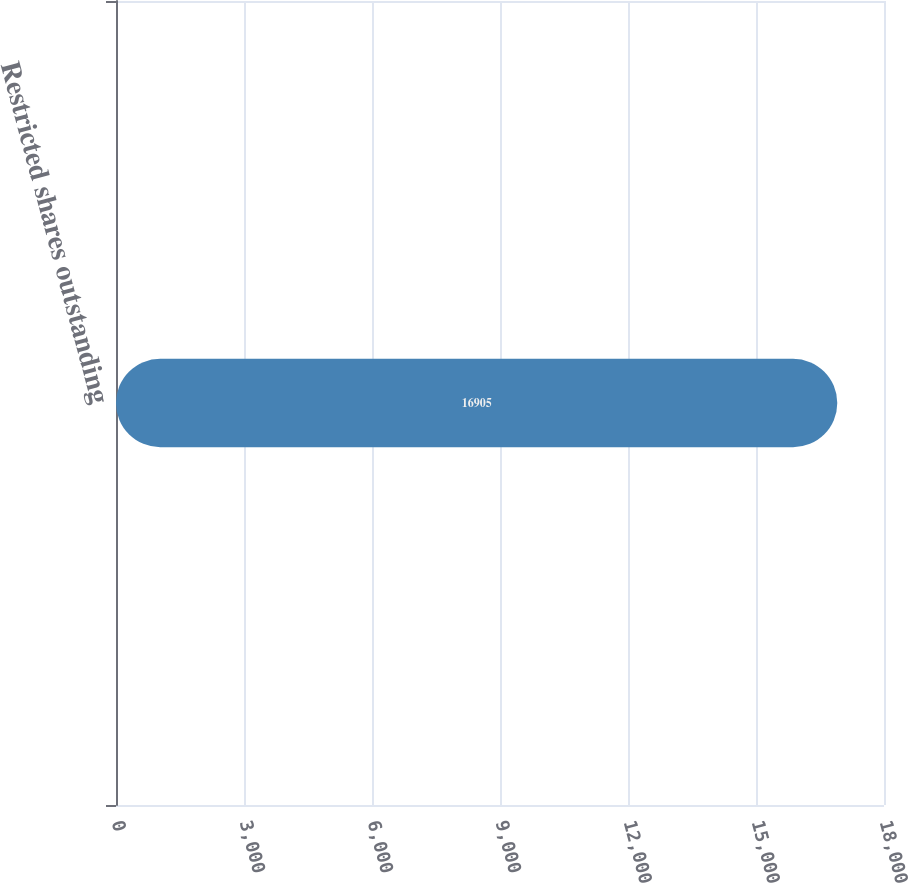<chart> <loc_0><loc_0><loc_500><loc_500><bar_chart><fcel>Restricted shares outstanding<nl><fcel>16905<nl></chart> 